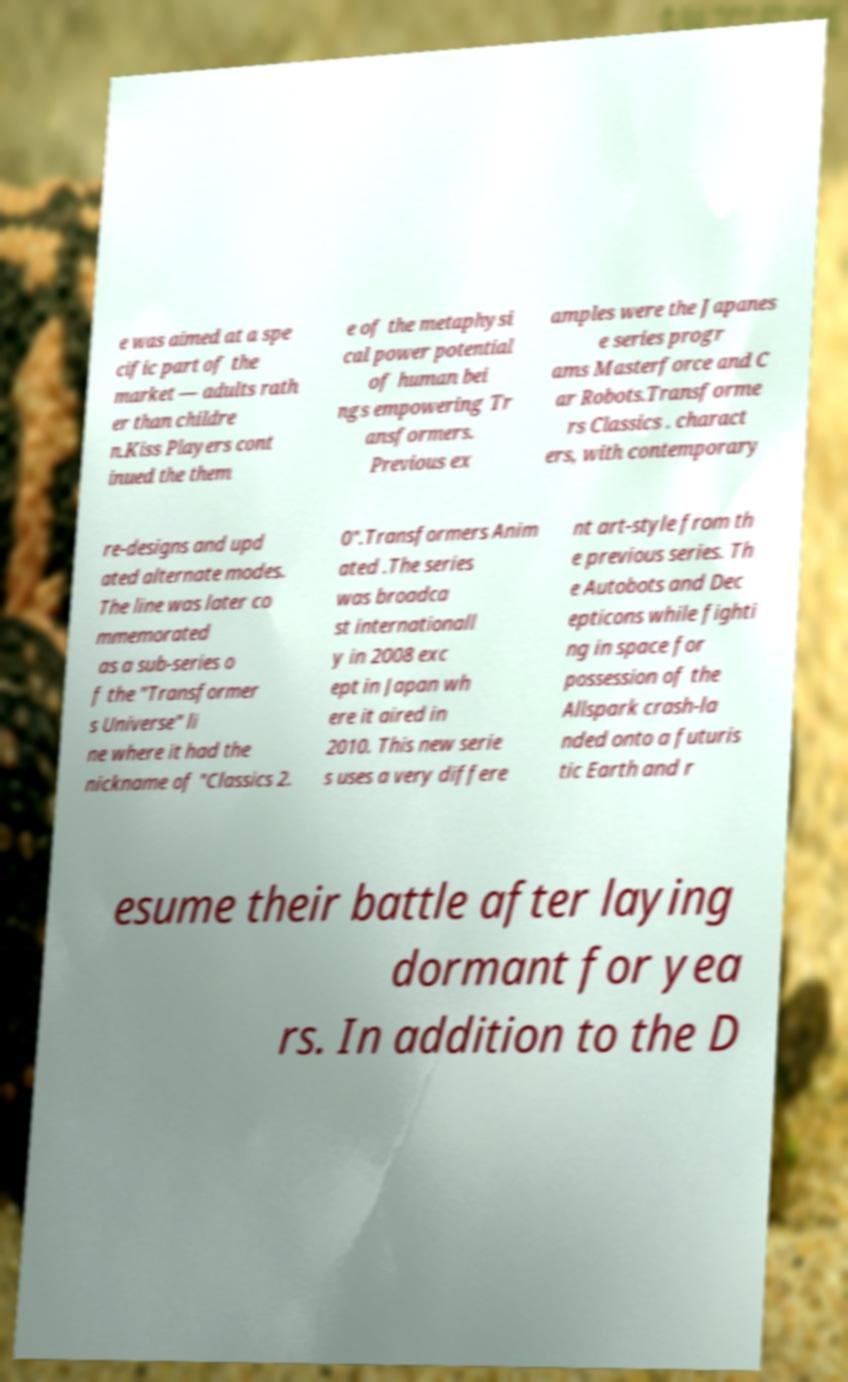Can you read and provide the text displayed in the image?This photo seems to have some interesting text. Can you extract and type it out for me? e was aimed at a spe cific part of the market — adults rath er than childre n.Kiss Players cont inued the them e of the metaphysi cal power potential of human bei ngs empowering Tr ansformers. Previous ex amples were the Japanes e series progr ams Masterforce and C ar Robots.Transforme rs Classics . charact ers, with contemporary re-designs and upd ated alternate modes. The line was later co mmemorated as a sub-series o f the "Transformer s Universe" li ne where it had the nickname of "Classics 2. 0".Transformers Anim ated .The series was broadca st internationall y in 2008 exc ept in Japan wh ere it aired in 2010. This new serie s uses a very differe nt art-style from th e previous series. Th e Autobots and Dec epticons while fighti ng in space for possession of the Allspark crash-la nded onto a futuris tic Earth and r esume their battle after laying dormant for yea rs. In addition to the D 